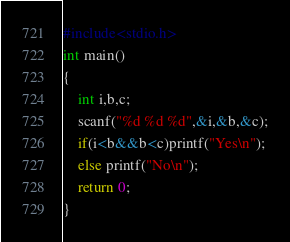Convert code to text. <code><loc_0><loc_0><loc_500><loc_500><_C_>#include<stdio.h>
int main()
{
    int i,b,c;
    scanf("%d %d %d",&i,&b,&c);
    if(i<b&&b<c)printf("Yes\n");
    else printf("No\n");
    return 0;
}

</code> 